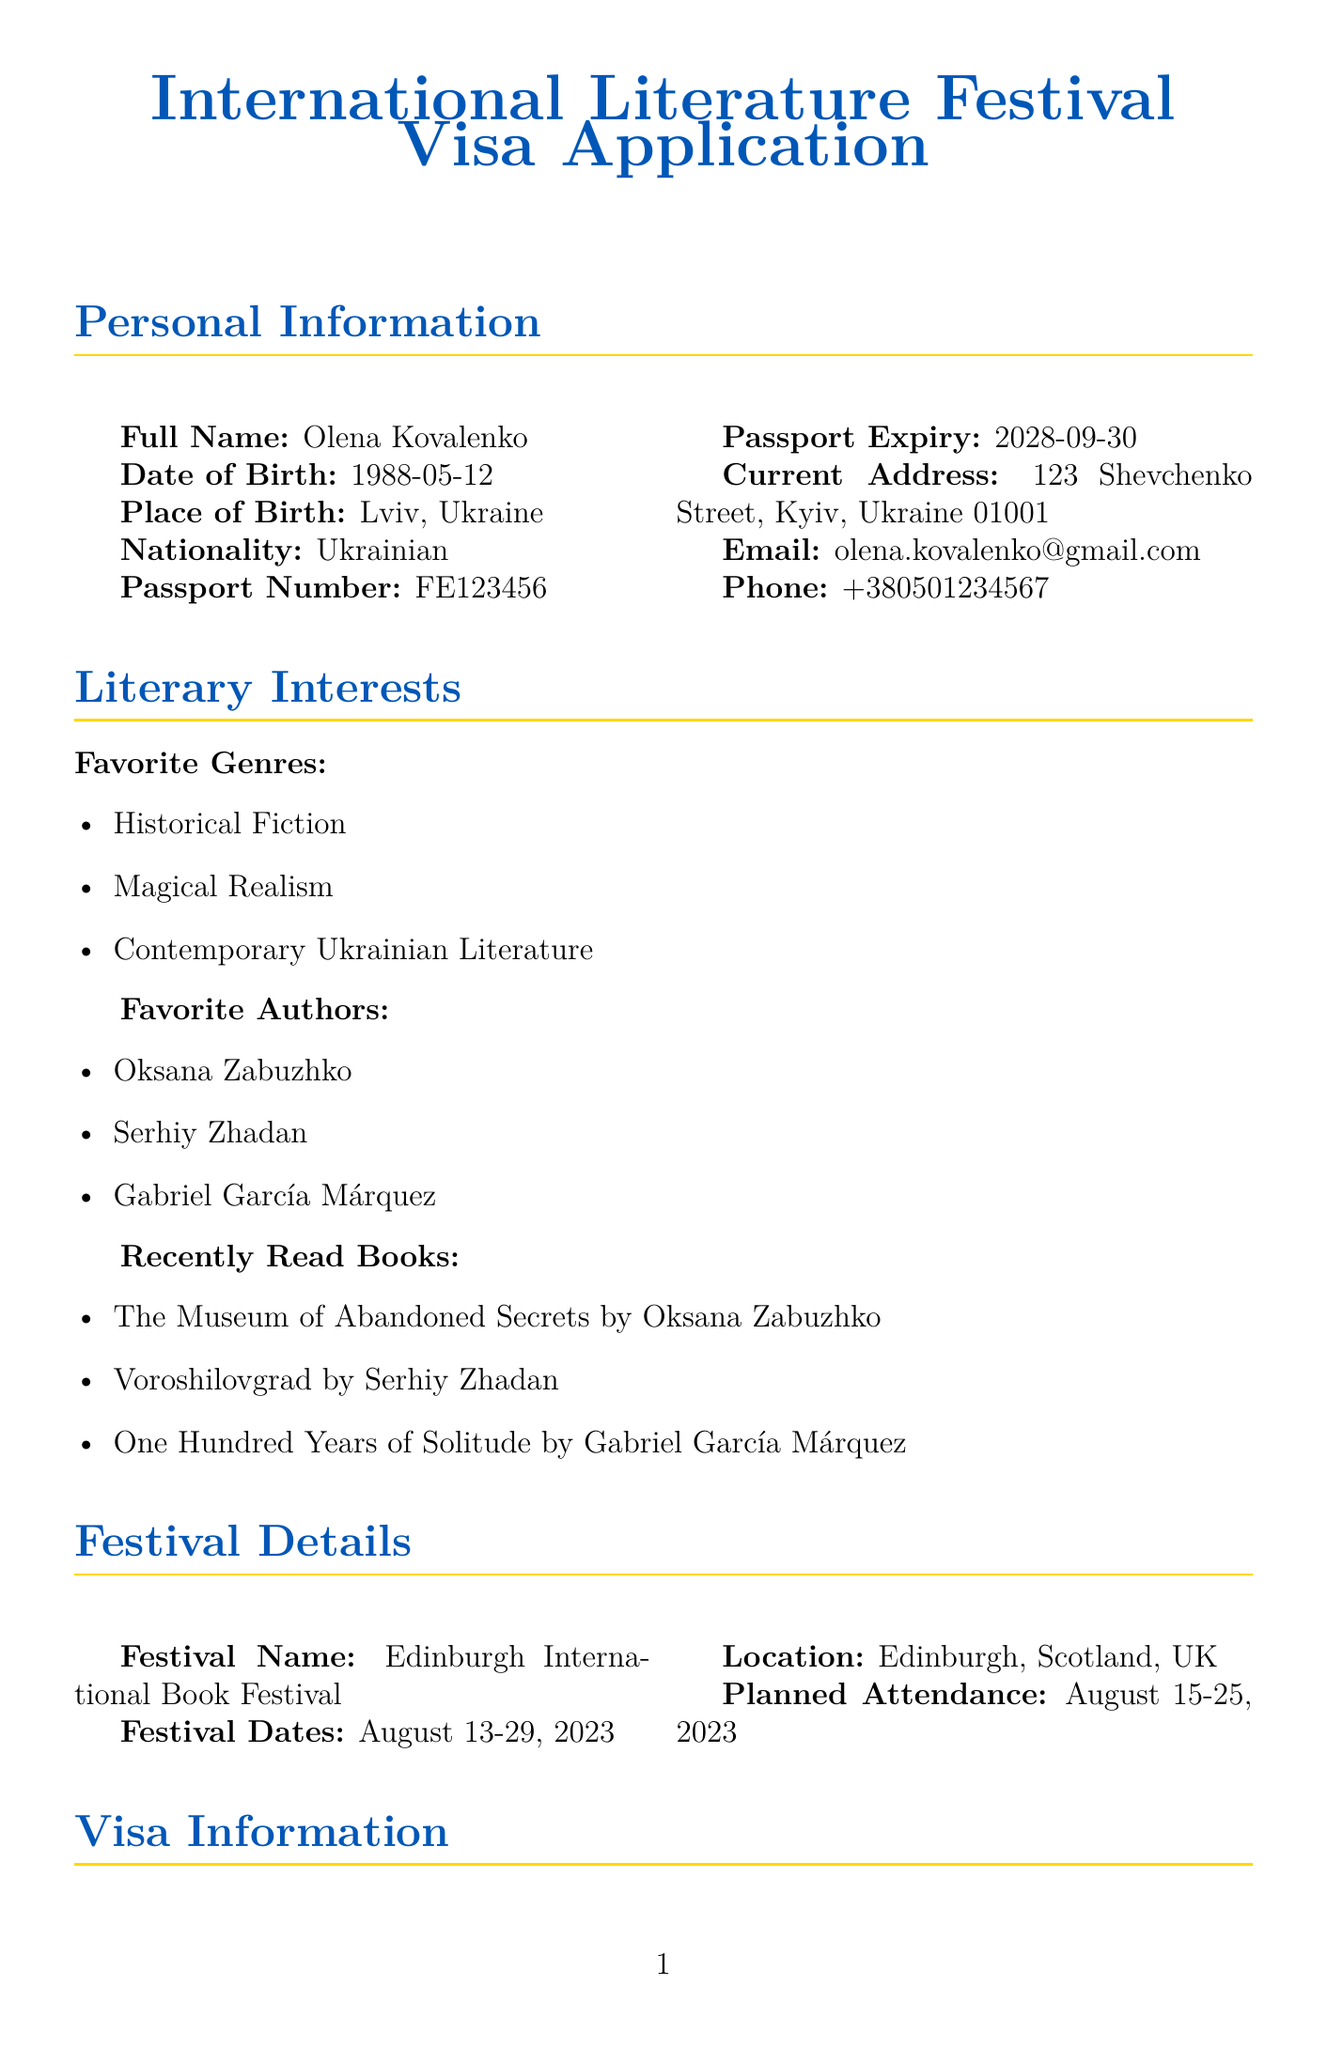What is the full name on the application? The full name is stated in the personal information section of the document.
Answer: Olena Kovalenko What is the date of birth of the applicant? The date of birth can be found in the personal information section.
Answer: 1988-05-12 What is the purpose of the visa application? The purpose of the visa is mentioned in the visa information section.
Answer: Attend Edinburgh International Book Festival What is the planned arrival date? The intended arrival date is indicated in the visa information section.
Answer: 2023-08-14 Which literary award was the applicant a finalist for? The specific award is noted in the literary awards section under literary background.
Answer: Finalist, BBC Ukrainian Book of the Year Award 2020 What types of literature does the applicant enjoy? The favorite genres are listed in the literary interests section.
Answer: Historical Fiction, Magical Realism, Contemporary Ukrainian Literature What is the name of the festival the applicant plans to attend? The festival name is provided in the festival details section.
Answer: Edinburgh International Book Festival What accommodation has been arranged for the festival? The accommodation details are given in the visa information section.
Answer: Motel One Edinburgh-Royal, 18-21 Market St, Edinburgh EH1 1BL, UK What languages does the applicant speak? The languages spoken by the applicant are listed in the additional information section.
Answer: Ukrainian, English, Russian, Polish 